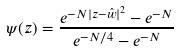<formula> <loc_0><loc_0><loc_500><loc_500>\psi ( z ) = \frac { e ^ { - N | z - \hat { w } | ^ { 2 } } - e ^ { - N } } { e ^ { - N / 4 } - e ^ { - N } }</formula> 